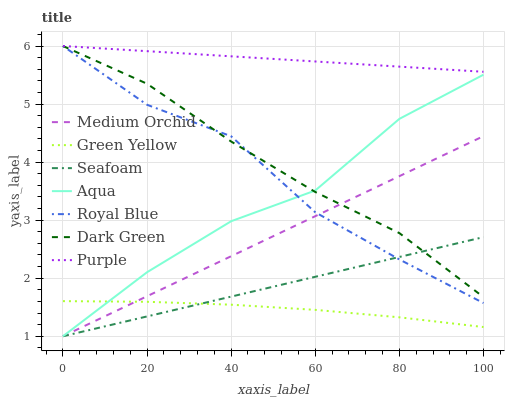Does Green Yellow have the minimum area under the curve?
Answer yes or no. Yes. Does Purple have the maximum area under the curve?
Answer yes or no. Yes. Does Medium Orchid have the minimum area under the curve?
Answer yes or no. No. Does Medium Orchid have the maximum area under the curve?
Answer yes or no. No. Is Medium Orchid the smoothest?
Answer yes or no. Yes. Is Royal Blue the roughest?
Answer yes or no. Yes. Is Aqua the smoothest?
Answer yes or no. No. Is Aqua the roughest?
Answer yes or no. No. Does Medium Orchid have the lowest value?
Answer yes or no. Yes. Does Royal Blue have the lowest value?
Answer yes or no. No. Does Dark Green have the highest value?
Answer yes or no. Yes. Does Medium Orchid have the highest value?
Answer yes or no. No. Is Green Yellow less than Purple?
Answer yes or no. Yes. Is Purple greater than Medium Orchid?
Answer yes or no. Yes. Does Dark Green intersect Purple?
Answer yes or no. Yes. Is Dark Green less than Purple?
Answer yes or no. No. Is Dark Green greater than Purple?
Answer yes or no. No. Does Green Yellow intersect Purple?
Answer yes or no. No. 